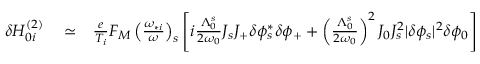Convert formula to latex. <formula><loc_0><loc_0><loc_500><loc_500>\begin{array} { r l r } { \delta H _ { 0 i } ^ { ( 2 ) } } & \simeq } & { \frac { e } { T _ { i } } F _ { M } \left ( \frac { \omega _ { * i } } { \omega } \right ) _ { s } \left [ i \frac { \Lambda _ { 0 } ^ { s } } { 2 \omega _ { 0 } } J _ { s } J _ { + } \delta \phi _ { s } ^ { * } \delta \phi _ { + } + \left ( \frac { \Lambda _ { 0 } ^ { s } } { 2 \omega _ { 0 } } \right ) ^ { 2 } J _ { 0 } J _ { s } ^ { 2 } | \delta \phi _ { s } | ^ { 2 } \delta \phi _ { 0 } \right ] } \end{array}</formula> 